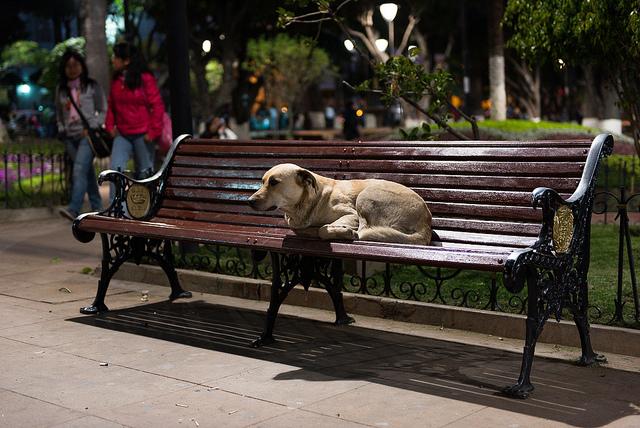Where is the dog sitting?
Short answer required. On bench. What animal is on the bench?
Be succinct. Dog. Is this dog wearing a collar?
Quick response, please. No. 